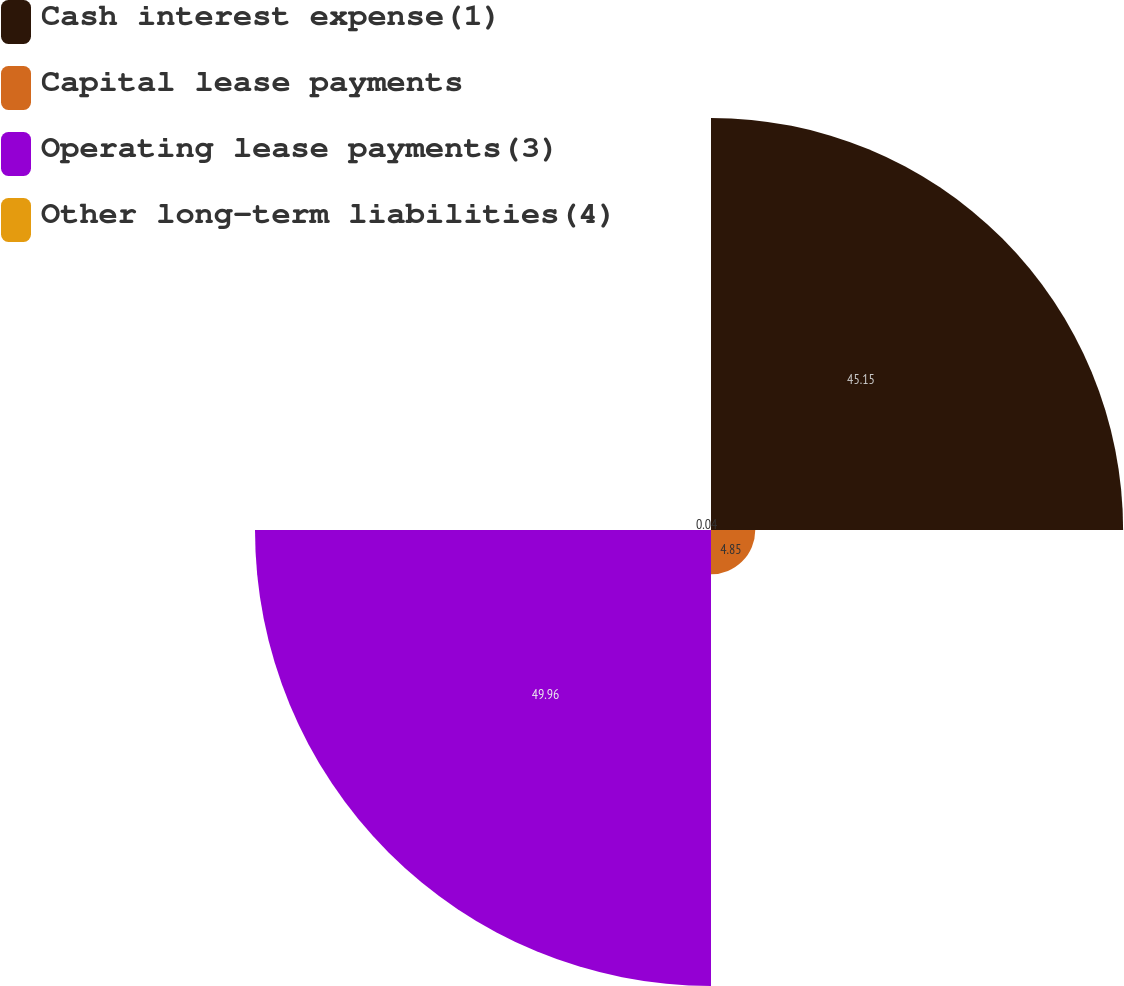Convert chart. <chart><loc_0><loc_0><loc_500><loc_500><pie_chart><fcel>Cash interest expense(1)<fcel>Capital lease payments<fcel>Operating lease payments(3)<fcel>Other long-term liabilities(4)<nl><fcel>45.15%<fcel>4.85%<fcel>49.96%<fcel>0.04%<nl></chart> 